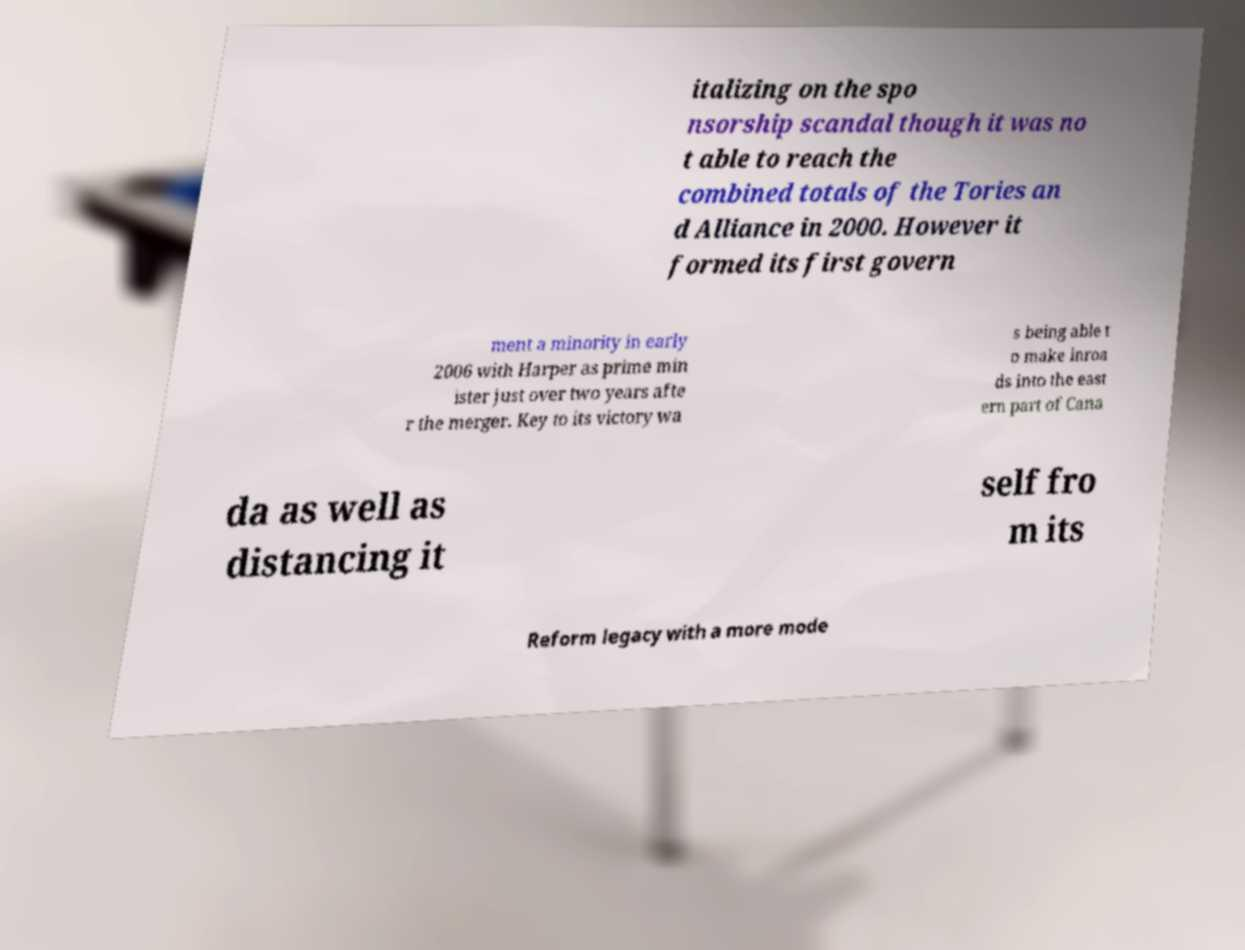Can you read and provide the text displayed in the image?This photo seems to have some interesting text. Can you extract and type it out for me? italizing on the spo nsorship scandal though it was no t able to reach the combined totals of the Tories an d Alliance in 2000. However it formed its first govern ment a minority in early 2006 with Harper as prime min ister just over two years afte r the merger. Key to its victory wa s being able t o make inroa ds into the east ern part of Cana da as well as distancing it self fro m its Reform legacy with a more mode 